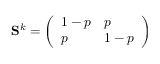<formula> <loc_0><loc_0><loc_500><loc_500>S ^ { k } = \left ( \begin{array} { l l } { 1 - p } & { p } \\ { p } & { 1 - p } \end{array} \right )</formula> 